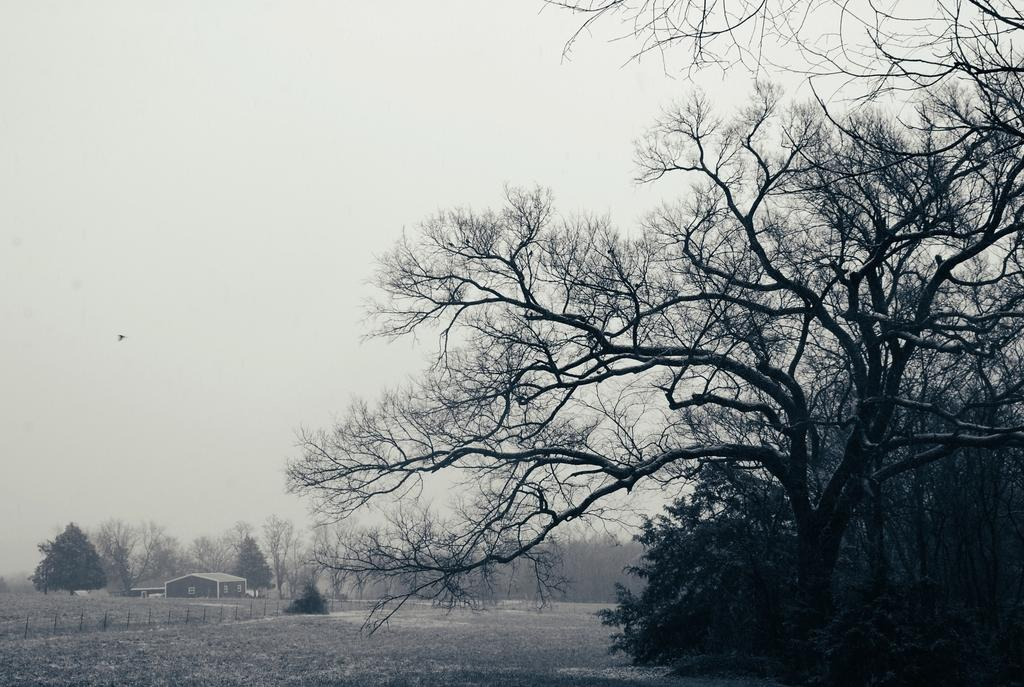What type of vegetation can be seen in the image? There are trees in the image. What part of the natural environment is visible in the image? The ground is visible in the image. What type of structure is present in the image? There is fencing in the image. What can be seen in the background of the image? There is a building, trees, and the sky visible in the background of the image. What type of net can be seen holding the bag in the image? There is no net or bag present in the image. What place is depicted in the image? The image does not depict a specific place; it shows trees, ground, fencing, and a background with a building, trees, and the sky. 